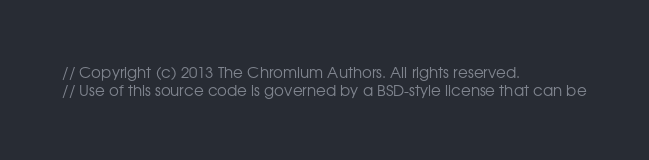Convert code to text. <code><loc_0><loc_0><loc_500><loc_500><_ObjectiveC_>// Copyright (c) 2013 The Chromium Authors. All rights reserved.
// Use of this source code is governed by a BSD-style license that can be</code> 